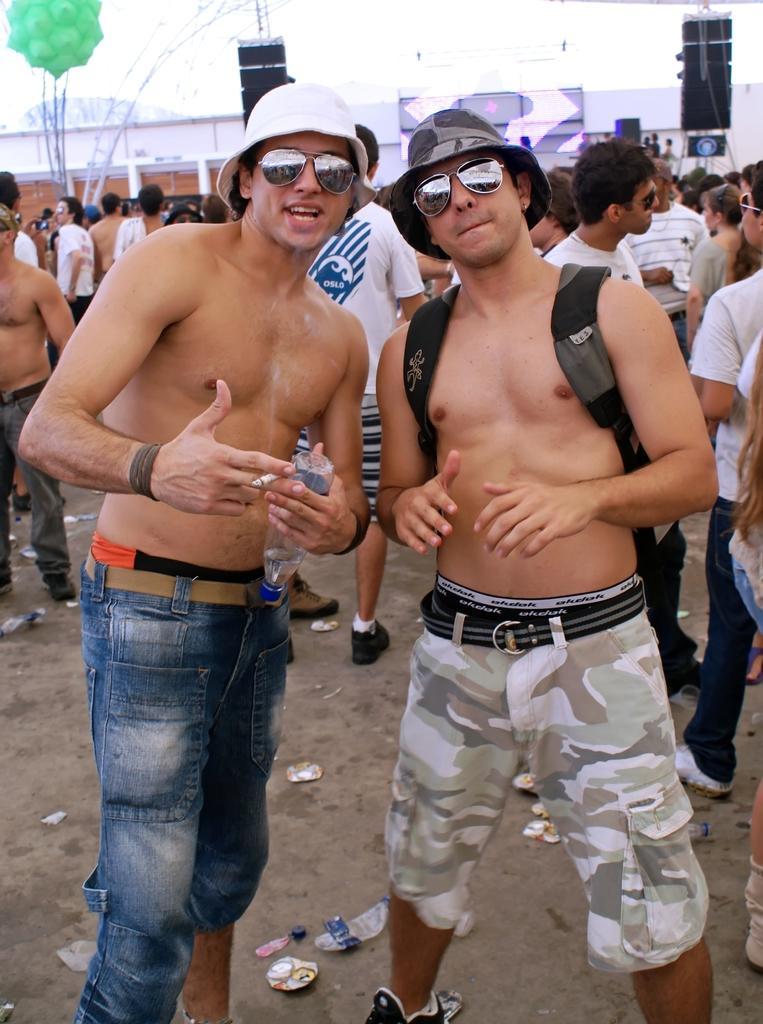Could you give a brief overview of what you see in this image? In this picture I can see few people are standing and couple of them wearing caps and sunglasses. I can see a man wearing a backpack and another man holding a cigarette and a bottle in his hands. I can see buildings, balloons and speakers to the poles and I can see a cloudy sky. 